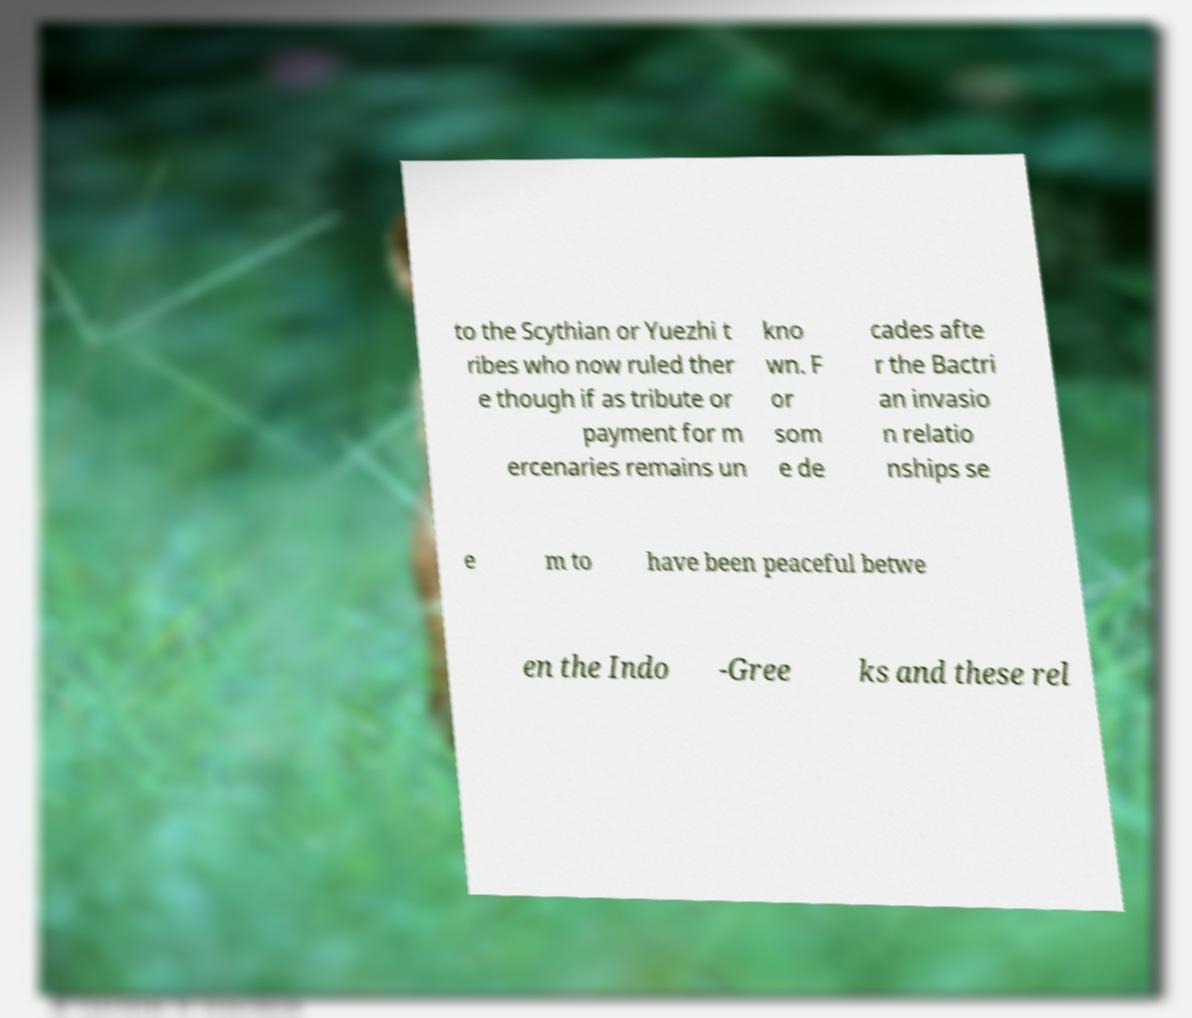Please identify and transcribe the text found in this image. to the Scythian or Yuezhi t ribes who now ruled ther e though if as tribute or payment for m ercenaries remains un kno wn. F or som e de cades afte r the Bactri an invasio n relatio nships se e m to have been peaceful betwe en the Indo -Gree ks and these rel 